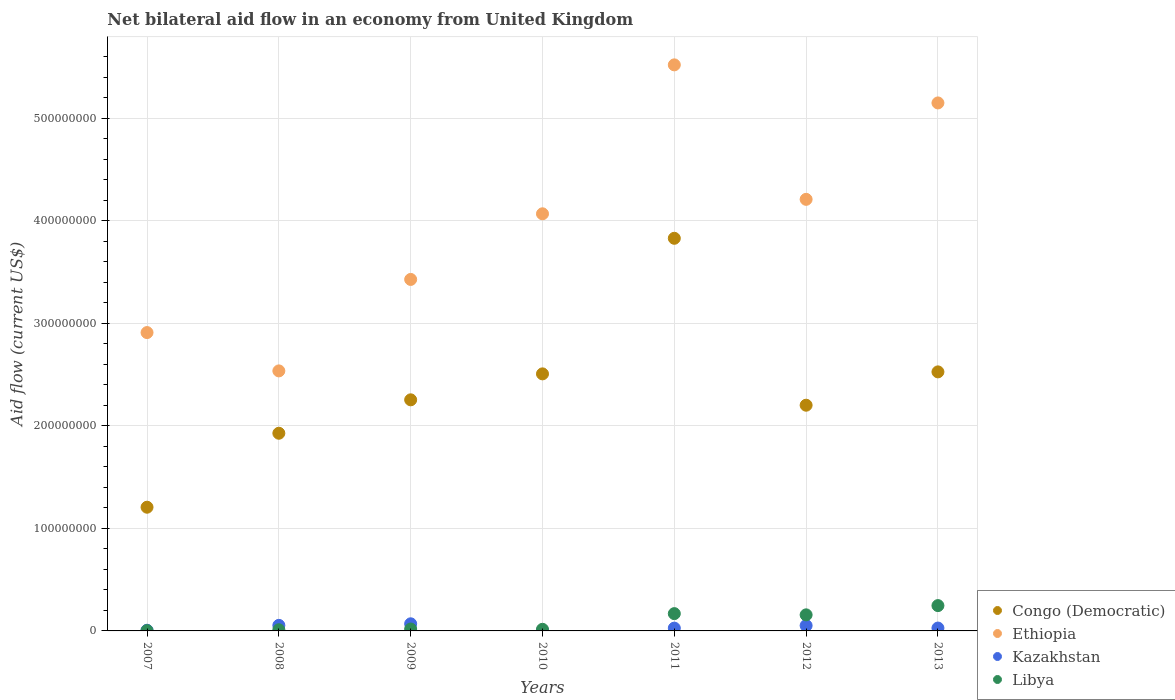How many different coloured dotlines are there?
Your response must be concise. 4. Is the number of dotlines equal to the number of legend labels?
Offer a very short reply. Yes. What is the net bilateral aid flow in Kazakhstan in 2012?
Provide a short and direct response. 5.22e+06. Across all years, what is the maximum net bilateral aid flow in Kazakhstan?
Your answer should be very brief. 6.95e+06. Across all years, what is the minimum net bilateral aid flow in Libya?
Keep it short and to the point. 2.90e+05. What is the total net bilateral aid flow in Ethiopia in the graph?
Make the answer very short. 2.78e+09. What is the difference between the net bilateral aid flow in Ethiopia in 2007 and that in 2010?
Your response must be concise. -1.16e+08. What is the difference between the net bilateral aid flow in Libya in 2013 and the net bilateral aid flow in Ethiopia in 2009?
Give a very brief answer. -3.18e+08. What is the average net bilateral aid flow in Ethiopia per year?
Give a very brief answer. 3.98e+08. In the year 2007, what is the difference between the net bilateral aid flow in Congo (Democratic) and net bilateral aid flow in Kazakhstan?
Offer a terse response. 1.20e+08. In how many years, is the net bilateral aid flow in Congo (Democratic) greater than 380000000 US$?
Offer a very short reply. 1. What is the ratio of the net bilateral aid flow in Kazakhstan in 2007 to that in 2011?
Provide a short and direct response. 0.24. Is the difference between the net bilateral aid flow in Congo (Democratic) in 2011 and 2013 greater than the difference between the net bilateral aid flow in Kazakhstan in 2011 and 2013?
Provide a succinct answer. Yes. What is the difference between the highest and the second highest net bilateral aid flow in Ethiopia?
Provide a short and direct response. 3.71e+07. What is the difference between the highest and the lowest net bilateral aid flow in Congo (Democratic)?
Your answer should be very brief. 2.62e+08. Is the sum of the net bilateral aid flow in Libya in 2008 and 2010 greater than the maximum net bilateral aid flow in Ethiopia across all years?
Give a very brief answer. No. Does the net bilateral aid flow in Libya monotonically increase over the years?
Provide a succinct answer. No. How many dotlines are there?
Offer a very short reply. 4. How many years are there in the graph?
Offer a very short reply. 7. Are the values on the major ticks of Y-axis written in scientific E-notation?
Make the answer very short. No. Does the graph contain any zero values?
Give a very brief answer. No. Does the graph contain grids?
Make the answer very short. Yes. Where does the legend appear in the graph?
Ensure brevity in your answer.  Bottom right. How are the legend labels stacked?
Offer a terse response. Vertical. What is the title of the graph?
Your answer should be compact. Net bilateral aid flow in an economy from United Kingdom. What is the Aid flow (current US$) in Congo (Democratic) in 2007?
Offer a very short reply. 1.21e+08. What is the Aid flow (current US$) of Ethiopia in 2007?
Your response must be concise. 2.91e+08. What is the Aid flow (current US$) of Congo (Democratic) in 2008?
Make the answer very short. 1.93e+08. What is the Aid flow (current US$) in Ethiopia in 2008?
Your answer should be very brief. 2.54e+08. What is the Aid flow (current US$) of Kazakhstan in 2008?
Your answer should be very brief. 5.42e+06. What is the Aid flow (current US$) of Libya in 2008?
Your answer should be compact. 1.14e+06. What is the Aid flow (current US$) in Congo (Democratic) in 2009?
Make the answer very short. 2.25e+08. What is the Aid flow (current US$) of Ethiopia in 2009?
Your answer should be compact. 3.43e+08. What is the Aid flow (current US$) in Kazakhstan in 2009?
Provide a short and direct response. 6.95e+06. What is the Aid flow (current US$) in Libya in 2009?
Ensure brevity in your answer.  1.86e+06. What is the Aid flow (current US$) in Congo (Democratic) in 2010?
Give a very brief answer. 2.51e+08. What is the Aid flow (current US$) in Ethiopia in 2010?
Offer a very short reply. 4.07e+08. What is the Aid flow (current US$) in Libya in 2010?
Offer a very short reply. 1.58e+06. What is the Aid flow (current US$) in Congo (Democratic) in 2011?
Keep it short and to the point. 3.83e+08. What is the Aid flow (current US$) in Ethiopia in 2011?
Your answer should be compact. 5.52e+08. What is the Aid flow (current US$) of Kazakhstan in 2011?
Your answer should be compact. 2.73e+06. What is the Aid flow (current US$) in Libya in 2011?
Make the answer very short. 1.69e+07. What is the Aid flow (current US$) in Congo (Democratic) in 2012?
Your response must be concise. 2.20e+08. What is the Aid flow (current US$) in Ethiopia in 2012?
Keep it short and to the point. 4.21e+08. What is the Aid flow (current US$) of Kazakhstan in 2012?
Offer a terse response. 5.22e+06. What is the Aid flow (current US$) in Libya in 2012?
Your response must be concise. 1.57e+07. What is the Aid flow (current US$) in Congo (Democratic) in 2013?
Your answer should be compact. 2.53e+08. What is the Aid flow (current US$) in Ethiopia in 2013?
Your response must be concise. 5.15e+08. What is the Aid flow (current US$) of Kazakhstan in 2013?
Keep it short and to the point. 2.80e+06. What is the Aid flow (current US$) in Libya in 2013?
Ensure brevity in your answer.  2.47e+07. Across all years, what is the maximum Aid flow (current US$) in Congo (Democratic)?
Your answer should be very brief. 3.83e+08. Across all years, what is the maximum Aid flow (current US$) in Ethiopia?
Your response must be concise. 5.52e+08. Across all years, what is the maximum Aid flow (current US$) in Kazakhstan?
Offer a very short reply. 6.95e+06. Across all years, what is the maximum Aid flow (current US$) of Libya?
Keep it short and to the point. 2.47e+07. Across all years, what is the minimum Aid flow (current US$) of Congo (Democratic)?
Give a very brief answer. 1.21e+08. Across all years, what is the minimum Aid flow (current US$) in Ethiopia?
Ensure brevity in your answer.  2.54e+08. Across all years, what is the minimum Aid flow (current US$) in Kazakhstan?
Keep it short and to the point. 3.40e+05. What is the total Aid flow (current US$) in Congo (Democratic) in the graph?
Offer a terse response. 1.65e+09. What is the total Aid flow (current US$) of Ethiopia in the graph?
Ensure brevity in your answer.  2.78e+09. What is the total Aid flow (current US$) of Kazakhstan in the graph?
Provide a short and direct response. 2.41e+07. What is the total Aid flow (current US$) in Libya in the graph?
Your answer should be compact. 6.21e+07. What is the difference between the Aid flow (current US$) of Congo (Democratic) in 2007 and that in 2008?
Your answer should be compact. -7.22e+07. What is the difference between the Aid flow (current US$) of Ethiopia in 2007 and that in 2008?
Offer a terse response. 3.74e+07. What is the difference between the Aid flow (current US$) in Kazakhstan in 2007 and that in 2008?
Provide a succinct answer. -4.76e+06. What is the difference between the Aid flow (current US$) in Libya in 2007 and that in 2008?
Your answer should be very brief. -8.50e+05. What is the difference between the Aid flow (current US$) in Congo (Democratic) in 2007 and that in 2009?
Offer a terse response. -1.05e+08. What is the difference between the Aid flow (current US$) of Ethiopia in 2007 and that in 2009?
Your answer should be compact. -5.18e+07. What is the difference between the Aid flow (current US$) of Kazakhstan in 2007 and that in 2009?
Ensure brevity in your answer.  -6.29e+06. What is the difference between the Aid flow (current US$) of Libya in 2007 and that in 2009?
Your answer should be compact. -1.57e+06. What is the difference between the Aid flow (current US$) of Congo (Democratic) in 2007 and that in 2010?
Keep it short and to the point. -1.30e+08. What is the difference between the Aid flow (current US$) in Ethiopia in 2007 and that in 2010?
Your response must be concise. -1.16e+08. What is the difference between the Aid flow (current US$) of Kazakhstan in 2007 and that in 2010?
Offer a terse response. 3.20e+05. What is the difference between the Aid flow (current US$) in Libya in 2007 and that in 2010?
Your answer should be compact. -1.29e+06. What is the difference between the Aid flow (current US$) in Congo (Democratic) in 2007 and that in 2011?
Make the answer very short. -2.62e+08. What is the difference between the Aid flow (current US$) of Ethiopia in 2007 and that in 2011?
Give a very brief answer. -2.61e+08. What is the difference between the Aid flow (current US$) in Kazakhstan in 2007 and that in 2011?
Your response must be concise. -2.07e+06. What is the difference between the Aid flow (current US$) of Libya in 2007 and that in 2011?
Make the answer very short. -1.66e+07. What is the difference between the Aid flow (current US$) in Congo (Democratic) in 2007 and that in 2012?
Provide a succinct answer. -9.95e+07. What is the difference between the Aid flow (current US$) in Ethiopia in 2007 and that in 2012?
Your answer should be compact. -1.30e+08. What is the difference between the Aid flow (current US$) in Kazakhstan in 2007 and that in 2012?
Your answer should be very brief. -4.56e+06. What is the difference between the Aid flow (current US$) of Libya in 2007 and that in 2012?
Provide a short and direct response. -1.54e+07. What is the difference between the Aid flow (current US$) of Congo (Democratic) in 2007 and that in 2013?
Make the answer very short. -1.32e+08. What is the difference between the Aid flow (current US$) of Ethiopia in 2007 and that in 2013?
Provide a short and direct response. -2.24e+08. What is the difference between the Aid flow (current US$) of Kazakhstan in 2007 and that in 2013?
Make the answer very short. -2.14e+06. What is the difference between the Aid flow (current US$) of Libya in 2007 and that in 2013?
Offer a terse response. -2.44e+07. What is the difference between the Aid flow (current US$) of Congo (Democratic) in 2008 and that in 2009?
Offer a very short reply. -3.26e+07. What is the difference between the Aid flow (current US$) of Ethiopia in 2008 and that in 2009?
Your answer should be compact. -8.92e+07. What is the difference between the Aid flow (current US$) in Kazakhstan in 2008 and that in 2009?
Your response must be concise. -1.53e+06. What is the difference between the Aid flow (current US$) of Libya in 2008 and that in 2009?
Keep it short and to the point. -7.20e+05. What is the difference between the Aid flow (current US$) of Congo (Democratic) in 2008 and that in 2010?
Keep it short and to the point. -5.79e+07. What is the difference between the Aid flow (current US$) in Ethiopia in 2008 and that in 2010?
Provide a short and direct response. -1.53e+08. What is the difference between the Aid flow (current US$) in Kazakhstan in 2008 and that in 2010?
Offer a terse response. 5.08e+06. What is the difference between the Aid flow (current US$) in Libya in 2008 and that in 2010?
Your answer should be very brief. -4.40e+05. What is the difference between the Aid flow (current US$) of Congo (Democratic) in 2008 and that in 2011?
Provide a succinct answer. -1.90e+08. What is the difference between the Aid flow (current US$) in Ethiopia in 2008 and that in 2011?
Keep it short and to the point. -2.99e+08. What is the difference between the Aid flow (current US$) of Kazakhstan in 2008 and that in 2011?
Offer a terse response. 2.69e+06. What is the difference between the Aid flow (current US$) in Libya in 2008 and that in 2011?
Provide a short and direct response. -1.57e+07. What is the difference between the Aid flow (current US$) of Congo (Democratic) in 2008 and that in 2012?
Your answer should be very brief. -2.74e+07. What is the difference between the Aid flow (current US$) of Ethiopia in 2008 and that in 2012?
Your response must be concise. -1.67e+08. What is the difference between the Aid flow (current US$) in Kazakhstan in 2008 and that in 2012?
Your response must be concise. 2.00e+05. What is the difference between the Aid flow (current US$) of Libya in 2008 and that in 2012?
Provide a short and direct response. -1.45e+07. What is the difference between the Aid flow (current US$) of Congo (Democratic) in 2008 and that in 2013?
Make the answer very short. -5.99e+07. What is the difference between the Aid flow (current US$) of Ethiopia in 2008 and that in 2013?
Provide a short and direct response. -2.61e+08. What is the difference between the Aid flow (current US$) in Kazakhstan in 2008 and that in 2013?
Your answer should be compact. 2.62e+06. What is the difference between the Aid flow (current US$) in Libya in 2008 and that in 2013?
Provide a succinct answer. -2.36e+07. What is the difference between the Aid flow (current US$) of Congo (Democratic) in 2009 and that in 2010?
Your answer should be very brief. -2.53e+07. What is the difference between the Aid flow (current US$) of Ethiopia in 2009 and that in 2010?
Offer a terse response. -6.40e+07. What is the difference between the Aid flow (current US$) of Kazakhstan in 2009 and that in 2010?
Your response must be concise. 6.61e+06. What is the difference between the Aid flow (current US$) of Congo (Democratic) in 2009 and that in 2011?
Ensure brevity in your answer.  -1.58e+08. What is the difference between the Aid flow (current US$) of Ethiopia in 2009 and that in 2011?
Offer a terse response. -2.09e+08. What is the difference between the Aid flow (current US$) of Kazakhstan in 2009 and that in 2011?
Your response must be concise. 4.22e+06. What is the difference between the Aid flow (current US$) in Libya in 2009 and that in 2011?
Ensure brevity in your answer.  -1.50e+07. What is the difference between the Aid flow (current US$) of Congo (Democratic) in 2009 and that in 2012?
Offer a terse response. 5.26e+06. What is the difference between the Aid flow (current US$) of Ethiopia in 2009 and that in 2012?
Provide a short and direct response. -7.81e+07. What is the difference between the Aid flow (current US$) of Kazakhstan in 2009 and that in 2012?
Your answer should be compact. 1.73e+06. What is the difference between the Aid flow (current US$) of Libya in 2009 and that in 2012?
Your answer should be compact. -1.38e+07. What is the difference between the Aid flow (current US$) in Congo (Democratic) in 2009 and that in 2013?
Keep it short and to the point. -2.73e+07. What is the difference between the Aid flow (current US$) of Ethiopia in 2009 and that in 2013?
Provide a succinct answer. -1.72e+08. What is the difference between the Aid flow (current US$) of Kazakhstan in 2009 and that in 2013?
Provide a short and direct response. 4.15e+06. What is the difference between the Aid flow (current US$) of Libya in 2009 and that in 2013?
Keep it short and to the point. -2.28e+07. What is the difference between the Aid flow (current US$) of Congo (Democratic) in 2010 and that in 2011?
Offer a very short reply. -1.32e+08. What is the difference between the Aid flow (current US$) in Ethiopia in 2010 and that in 2011?
Offer a terse response. -1.45e+08. What is the difference between the Aid flow (current US$) of Kazakhstan in 2010 and that in 2011?
Your response must be concise. -2.39e+06. What is the difference between the Aid flow (current US$) in Libya in 2010 and that in 2011?
Provide a succinct answer. -1.53e+07. What is the difference between the Aid flow (current US$) in Congo (Democratic) in 2010 and that in 2012?
Offer a terse response. 3.06e+07. What is the difference between the Aid flow (current US$) of Ethiopia in 2010 and that in 2012?
Ensure brevity in your answer.  -1.41e+07. What is the difference between the Aid flow (current US$) in Kazakhstan in 2010 and that in 2012?
Provide a short and direct response. -4.88e+06. What is the difference between the Aid flow (current US$) of Libya in 2010 and that in 2012?
Provide a succinct answer. -1.41e+07. What is the difference between the Aid flow (current US$) in Congo (Democratic) in 2010 and that in 2013?
Ensure brevity in your answer.  -1.94e+06. What is the difference between the Aid flow (current US$) of Ethiopia in 2010 and that in 2013?
Provide a succinct answer. -1.08e+08. What is the difference between the Aid flow (current US$) in Kazakhstan in 2010 and that in 2013?
Offer a very short reply. -2.46e+06. What is the difference between the Aid flow (current US$) in Libya in 2010 and that in 2013?
Offer a very short reply. -2.31e+07. What is the difference between the Aid flow (current US$) of Congo (Democratic) in 2011 and that in 2012?
Provide a short and direct response. 1.63e+08. What is the difference between the Aid flow (current US$) of Ethiopia in 2011 and that in 2012?
Provide a short and direct response. 1.31e+08. What is the difference between the Aid flow (current US$) in Kazakhstan in 2011 and that in 2012?
Make the answer very short. -2.49e+06. What is the difference between the Aid flow (current US$) of Libya in 2011 and that in 2012?
Your answer should be compact. 1.19e+06. What is the difference between the Aid flow (current US$) of Congo (Democratic) in 2011 and that in 2013?
Make the answer very short. 1.30e+08. What is the difference between the Aid flow (current US$) of Ethiopia in 2011 and that in 2013?
Your answer should be compact. 3.71e+07. What is the difference between the Aid flow (current US$) of Libya in 2011 and that in 2013?
Provide a succinct answer. -7.83e+06. What is the difference between the Aid flow (current US$) of Congo (Democratic) in 2012 and that in 2013?
Provide a short and direct response. -3.25e+07. What is the difference between the Aid flow (current US$) in Ethiopia in 2012 and that in 2013?
Provide a short and direct response. -9.41e+07. What is the difference between the Aid flow (current US$) in Kazakhstan in 2012 and that in 2013?
Make the answer very short. 2.42e+06. What is the difference between the Aid flow (current US$) in Libya in 2012 and that in 2013?
Give a very brief answer. -9.02e+06. What is the difference between the Aid flow (current US$) of Congo (Democratic) in 2007 and the Aid flow (current US$) of Ethiopia in 2008?
Your answer should be compact. -1.33e+08. What is the difference between the Aid flow (current US$) in Congo (Democratic) in 2007 and the Aid flow (current US$) in Kazakhstan in 2008?
Keep it short and to the point. 1.15e+08. What is the difference between the Aid flow (current US$) of Congo (Democratic) in 2007 and the Aid flow (current US$) of Libya in 2008?
Your answer should be compact. 1.20e+08. What is the difference between the Aid flow (current US$) of Ethiopia in 2007 and the Aid flow (current US$) of Kazakhstan in 2008?
Offer a terse response. 2.86e+08. What is the difference between the Aid flow (current US$) in Ethiopia in 2007 and the Aid flow (current US$) in Libya in 2008?
Make the answer very short. 2.90e+08. What is the difference between the Aid flow (current US$) in Kazakhstan in 2007 and the Aid flow (current US$) in Libya in 2008?
Your response must be concise. -4.80e+05. What is the difference between the Aid flow (current US$) of Congo (Democratic) in 2007 and the Aid flow (current US$) of Ethiopia in 2009?
Make the answer very short. -2.22e+08. What is the difference between the Aid flow (current US$) in Congo (Democratic) in 2007 and the Aid flow (current US$) in Kazakhstan in 2009?
Give a very brief answer. 1.14e+08. What is the difference between the Aid flow (current US$) of Congo (Democratic) in 2007 and the Aid flow (current US$) of Libya in 2009?
Offer a terse response. 1.19e+08. What is the difference between the Aid flow (current US$) of Ethiopia in 2007 and the Aid flow (current US$) of Kazakhstan in 2009?
Your answer should be compact. 2.84e+08. What is the difference between the Aid flow (current US$) of Ethiopia in 2007 and the Aid flow (current US$) of Libya in 2009?
Provide a short and direct response. 2.89e+08. What is the difference between the Aid flow (current US$) of Kazakhstan in 2007 and the Aid flow (current US$) of Libya in 2009?
Keep it short and to the point. -1.20e+06. What is the difference between the Aid flow (current US$) in Congo (Democratic) in 2007 and the Aid flow (current US$) in Ethiopia in 2010?
Your response must be concise. -2.86e+08. What is the difference between the Aid flow (current US$) in Congo (Democratic) in 2007 and the Aid flow (current US$) in Kazakhstan in 2010?
Offer a terse response. 1.20e+08. What is the difference between the Aid flow (current US$) in Congo (Democratic) in 2007 and the Aid flow (current US$) in Libya in 2010?
Your answer should be very brief. 1.19e+08. What is the difference between the Aid flow (current US$) of Ethiopia in 2007 and the Aid flow (current US$) of Kazakhstan in 2010?
Offer a very short reply. 2.91e+08. What is the difference between the Aid flow (current US$) in Ethiopia in 2007 and the Aid flow (current US$) in Libya in 2010?
Give a very brief answer. 2.89e+08. What is the difference between the Aid flow (current US$) in Kazakhstan in 2007 and the Aid flow (current US$) in Libya in 2010?
Your answer should be very brief. -9.20e+05. What is the difference between the Aid flow (current US$) of Congo (Democratic) in 2007 and the Aid flow (current US$) of Ethiopia in 2011?
Provide a succinct answer. -4.32e+08. What is the difference between the Aid flow (current US$) in Congo (Democratic) in 2007 and the Aid flow (current US$) in Kazakhstan in 2011?
Provide a succinct answer. 1.18e+08. What is the difference between the Aid flow (current US$) in Congo (Democratic) in 2007 and the Aid flow (current US$) in Libya in 2011?
Your answer should be very brief. 1.04e+08. What is the difference between the Aid flow (current US$) in Ethiopia in 2007 and the Aid flow (current US$) in Kazakhstan in 2011?
Your answer should be very brief. 2.88e+08. What is the difference between the Aid flow (current US$) of Ethiopia in 2007 and the Aid flow (current US$) of Libya in 2011?
Offer a very short reply. 2.74e+08. What is the difference between the Aid flow (current US$) of Kazakhstan in 2007 and the Aid flow (current US$) of Libya in 2011?
Give a very brief answer. -1.62e+07. What is the difference between the Aid flow (current US$) in Congo (Democratic) in 2007 and the Aid flow (current US$) in Ethiopia in 2012?
Provide a succinct answer. -3.00e+08. What is the difference between the Aid flow (current US$) of Congo (Democratic) in 2007 and the Aid flow (current US$) of Kazakhstan in 2012?
Give a very brief answer. 1.15e+08. What is the difference between the Aid flow (current US$) in Congo (Democratic) in 2007 and the Aid flow (current US$) in Libya in 2012?
Ensure brevity in your answer.  1.05e+08. What is the difference between the Aid flow (current US$) in Ethiopia in 2007 and the Aid flow (current US$) in Kazakhstan in 2012?
Ensure brevity in your answer.  2.86e+08. What is the difference between the Aid flow (current US$) in Ethiopia in 2007 and the Aid flow (current US$) in Libya in 2012?
Ensure brevity in your answer.  2.75e+08. What is the difference between the Aid flow (current US$) in Kazakhstan in 2007 and the Aid flow (current US$) in Libya in 2012?
Make the answer very short. -1.50e+07. What is the difference between the Aid flow (current US$) in Congo (Democratic) in 2007 and the Aid flow (current US$) in Ethiopia in 2013?
Your answer should be compact. -3.94e+08. What is the difference between the Aid flow (current US$) in Congo (Democratic) in 2007 and the Aid flow (current US$) in Kazakhstan in 2013?
Offer a terse response. 1.18e+08. What is the difference between the Aid flow (current US$) in Congo (Democratic) in 2007 and the Aid flow (current US$) in Libya in 2013?
Keep it short and to the point. 9.60e+07. What is the difference between the Aid flow (current US$) of Ethiopia in 2007 and the Aid flow (current US$) of Kazakhstan in 2013?
Make the answer very short. 2.88e+08. What is the difference between the Aid flow (current US$) in Ethiopia in 2007 and the Aid flow (current US$) in Libya in 2013?
Offer a terse response. 2.66e+08. What is the difference between the Aid flow (current US$) in Kazakhstan in 2007 and the Aid flow (current US$) in Libya in 2013?
Offer a terse response. -2.40e+07. What is the difference between the Aid flow (current US$) of Congo (Democratic) in 2008 and the Aid flow (current US$) of Ethiopia in 2009?
Your response must be concise. -1.50e+08. What is the difference between the Aid flow (current US$) in Congo (Democratic) in 2008 and the Aid flow (current US$) in Kazakhstan in 2009?
Your response must be concise. 1.86e+08. What is the difference between the Aid flow (current US$) in Congo (Democratic) in 2008 and the Aid flow (current US$) in Libya in 2009?
Provide a short and direct response. 1.91e+08. What is the difference between the Aid flow (current US$) of Ethiopia in 2008 and the Aid flow (current US$) of Kazakhstan in 2009?
Your response must be concise. 2.47e+08. What is the difference between the Aid flow (current US$) in Ethiopia in 2008 and the Aid flow (current US$) in Libya in 2009?
Ensure brevity in your answer.  2.52e+08. What is the difference between the Aid flow (current US$) in Kazakhstan in 2008 and the Aid flow (current US$) in Libya in 2009?
Your answer should be compact. 3.56e+06. What is the difference between the Aid flow (current US$) in Congo (Democratic) in 2008 and the Aid flow (current US$) in Ethiopia in 2010?
Keep it short and to the point. -2.14e+08. What is the difference between the Aid flow (current US$) in Congo (Democratic) in 2008 and the Aid flow (current US$) in Kazakhstan in 2010?
Your response must be concise. 1.93e+08. What is the difference between the Aid flow (current US$) of Congo (Democratic) in 2008 and the Aid flow (current US$) of Libya in 2010?
Your response must be concise. 1.91e+08. What is the difference between the Aid flow (current US$) of Ethiopia in 2008 and the Aid flow (current US$) of Kazakhstan in 2010?
Offer a very short reply. 2.53e+08. What is the difference between the Aid flow (current US$) of Ethiopia in 2008 and the Aid flow (current US$) of Libya in 2010?
Your answer should be compact. 2.52e+08. What is the difference between the Aid flow (current US$) of Kazakhstan in 2008 and the Aid flow (current US$) of Libya in 2010?
Keep it short and to the point. 3.84e+06. What is the difference between the Aid flow (current US$) in Congo (Democratic) in 2008 and the Aid flow (current US$) in Ethiopia in 2011?
Your answer should be very brief. -3.59e+08. What is the difference between the Aid flow (current US$) of Congo (Democratic) in 2008 and the Aid flow (current US$) of Kazakhstan in 2011?
Provide a short and direct response. 1.90e+08. What is the difference between the Aid flow (current US$) in Congo (Democratic) in 2008 and the Aid flow (current US$) in Libya in 2011?
Make the answer very short. 1.76e+08. What is the difference between the Aid flow (current US$) of Ethiopia in 2008 and the Aid flow (current US$) of Kazakhstan in 2011?
Offer a very short reply. 2.51e+08. What is the difference between the Aid flow (current US$) in Ethiopia in 2008 and the Aid flow (current US$) in Libya in 2011?
Keep it short and to the point. 2.37e+08. What is the difference between the Aid flow (current US$) in Kazakhstan in 2008 and the Aid flow (current US$) in Libya in 2011?
Offer a very short reply. -1.14e+07. What is the difference between the Aid flow (current US$) in Congo (Democratic) in 2008 and the Aid flow (current US$) in Ethiopia in 2012?
Make the answer very short. -2.28e+08. What is the difference between the Aid flow (current US$) of Congo (Democratic) in 2008 and the Aid flow (current US$) of Kazakhstan in 2012?
Provide a succinct answer. 1.88e+08. What is the difference between the Aid flow (current US$) of Congo (Democratic) in 2008 and the Aid flow (current US$) of Libya in 2012?
Keep it short and to the point. 1.77e+08. What is the difference between the Aid flow (current US$) in Ethiopia in 2008 and the Aid flow (current US$) in Kazakhstan in 2012?
Offer a very short reply. 2.48e+08. What is the difference between the Aid flow (current US$) of Ethiopia in 2008 and the Aid flow (current US$) of Libya in 2012?
Ensure brevity in your answer.  2.38e+08. What is the difference between the Aid flow (current US$) of Kazakhstan in 2008 and the Aid flow (current US$) of Libya in 2012?
Offer a terse response. -1.03e+07. What is the difference between the Aid flow (current US$) in Congo (Democratic) in 2008 and the Aid flow (current US$) in Ethiopia in 2013?
Give a very brief answer. -3.22e+08. What is the difference between the Aid flow (current US$) of Congo (Democratic) in 2008 and the Aid flow (current US$) of Kazakhstan in 2013?
Provide a short and direct response. 1.90e+08. What is the difference between the Aid flow (current US$) of Congo (Democratic) in 2008 and the Aid flow (current US$) of Libya in 2013?
Make the answer very short. 1.68e+08. What is the difference between the Aid flow (current US$) in Ethiopia in 2008 and the Aid flow (current US$) in Kazakhstan in 2013?
Provide a succinct answer. 2.51e+08. What is the difference between the Aid flow (current US$) of Ethiopia in 2008 and the Aid flow (current US$) of Libya in 2013?
Offer a very short reply. 2.29e+08. What is the difference between the Aid flow (current US$) in Kazakhstan in 2008 and the Aid flow (current US$) in Libya in 2013?
Your answer should be very brief. -1.93e+07. What is the difference between the Aid flow (current US$) of Congo (Democratic) in 2009 and the Aid flow (current US$) of Ethiopia in 2010?
Offer a terse response. -1.81e+08. What is the difference between the Aid flow (current US$) of Congo (Democratic) in 2009 and the Aid flow (current US$) of Kazakhstan in 2010?
Provide a short and direct response. 2.25e+08. What is the difference between the Aid flow (current US$) of Congo (Democratic) in 2009 and the Aid flow (current US$) of Libya in 2010?
Provide a short and direct response. 2.24e+08. What is the difference between the Aid flow (current US$) in Ethiopia in 2009 and the Aid flow (current US$) in Kazakhstan in 2010?
Provide a succinct answer. 3.43e+08. What is the difference between the Aid flow (current US$) in Ethiopia in 2009 and the Aid flow (current US$) in Libya in 2010?
Keep it short and to the point. 3.41e+08. What is the difference between the Aid flow (current US$) of Kazakhstan in 2009 and the Aid flow (current US$) of Libya in 2010?
Your answer should be compact. 5.37e+06. What is the difference between the Aid flow (current US$) in Congo (Democratic) in 2009 and the Aid flow (current US$) in Ethiopia in 2011?
Offer a terse response. -3.27e+08. What is the difference between the Aid flow (current US$) of Congo (Democratic) in 2009 and the Aid flow (current US$) of Kazakhstan in 2011?
Your response must be concise. 2.23e+08. What is the difference between the Aid flow (current US$) of Congo (Democratic) in 2009 and the Aid flow (current US$) of Libya in 2011?
Make the answer very short. 2.09e+08. What is the difference between the Aid flow (current US$) in Ethiopia in 2009 and the Aid flow (current US$) in Kazakhstan in 2011?
Your answer should be compact. 3.40e+08. What is the difference between the Aid flow (current US$) in Ethiopia in 2009 and the Aid flow (current US$) in Libya in 2011?
Your response must be concise. 3.26e+08. What is the difference between the Aid flow (current US$) of Kazakhstan in 2009 and the Aid flow (current US$) of Libya in 2011?
Your response must be concise. -9.92e+06. What is the difference between the Aid flow (current US$) in Congo (Democratic) in 2009 and the Aid flow (current US$) in Ethiopia in 2012?
Provide a succinct answer. -1.96e+08. What is the difference between the Aid flow (current US$) of Congo (Democratic) in 2009 and the Aid flow (current US$) of Kazakhstan in 2012?
Offer a terse response. 2.20e+08. What is the difference between the Aid flow (current US$) of Congo (Democratic) in 2009 and the Aid flow (current US$) of Libya in 2012?
Keep it short and to the point. 2.10e+08. What is the difference between the Aid flow (current US$) of Ethiopia in 2009 and the Aid flow (current US$) of Kazakhstan in 2012?
Your answer should be compact. 3.38e+08. What is the difference between the Aid flow (current US$) of Ethiopia in 2009 and the Aid flow (current US$) of Libya in 2012?
Your answer should be compact. 3.27e+08. What is the difference between the Aid flow (current US$) in Kazakhstan in 2009 and the Aid flow (current US$) in Libya in 2012?
Provide a short and direct response. -8.73e+06. What is the difference between the Aid flow (current US$) in Congo (Democratic) in 2009 and the Aid flow (current US$) in Ethiopia in 2013?
Your answer should be very brief. -2.90e+08. What is the difference between the Aid flow (current US$) in Congo (Democratic) in 2009 and the Aid flow (current US$) in Kazakhstan in 2013?
Your answer should be very brief. 2.23e+08. What is the difference between the Aid flow (current US$) in Congo (Democratic) in 2009 and the Aid flow (current US$) in Libya in 2013?
Offer a terse response. 2.01e+08. What is the difference between the Aid flow (current US$) of Ethiopia in 2009 and the Aid flow (current US$) of Kazakhstan in 2013?
Give a very brief answer. 3.40e+08. What is the difference between the Aid flow (current US$) in Ethiopia in 2009 and the Aid flow (current US$) in Libya in 2013?
Your answer should be very brief. 3.18e+08. What is the difference between the Aid flow (current US$) of Kazakhstan in 2009 and the Aid flow (current US$) of Libya in 2013?
Ensure brevity in your answer.  -1.78e+07. What is the difference between the Aid flow (current US$) of Congo (Democratic) in 2010 and the Aid flow (current US$) of Ethiopia in 2011?
Keep it short and to the point. -3.01e+08. What is the difference between the Aid flow (current US$) of Congo (Democratic) in 2010 and the Aid flow (current US$) of Kazakhstan in 2011?
Offer a terse response. 2.48e+08. What is the difference between the Aid flow (current US$) of Congo (Democratic) in 2010 and the Aid flow (current US$) of Libya in 2011?
Provide a short and direct response. 2.34e+08. What is the difference between the Aid flow (current US$) of Ethiopia in 2010 and the Aid flow (current US$) of Kazakhstan in 2011?
Make the answer very short. 4.04e+08. What is the difference between the Aid flow (current US$) in Ethiopia in 2010 and the Aid flow (current US$) in Libya in 2011?
Provide a short and direct response. 3.90e+08. What is the difference between the Aid flow (current US$) in Kazakhstan in 2010 and the Aid flow (current US$) in Libya in 2011?
Offer a terse response. -1.65e+07. What is the difference between the Aid flow (current US$) of Congo (Democratic) in 2010 and the Aid flow (current US$) of Ethiopia in 2012?
Your answer should be very brief. -1.70e+08. What is the difference between the Aid flow (current US$) in Congo (Democratic) in 2010 and the Aid flow (current US$) in Kazakhstan in 2012?
Make the answer very short. 2.46e+08. What is the difference between the Aid flow (current US$) of Congo (Democratic) in 2010 and the Aid flow (current US$) of Libya in 2012?
Provide a succinct answer. 2.35e+08. What is the difference between the Aid flow (current US$) in Ethiopia in 2010 and the Aid flow (current US$) in Kazakhstan in 2012?
Your answer should be compact. 4.02e+08. What is the difference between the Aid flow (current US$) of Ethiopia in 2010 and the Aid flow (current US$) of Libya in 2012?
Your answer should be very brief. 3.91e+08. What is the difference between the Aid flow (current US$) of Kazakhstan in 2010 and the Aid flow (current US$) of Libya in 2012?
Ensure brevity in your answer.  -1.53e+07. What is the difference between the Aid flow (current US$) in Congo (Democratic) in 2010 and the Aid flow (current US$) in Ethiopia in 2013?
Keep it short and to the point. -2.64e+08. What is the difference between the Aid flow (current US$) of Congo (Democratic) in 2010 and the Aid flow (current US$) of Kazakhstan in 2013?
Provide a short and direct response. 2.48e+08. What is the difference between the Aid flow (current US$) in Congo (Democratic) in 2010 and the Aid flow (current US$) in Libya in 2013?
Your answer should be very brief. 2.26e+08. What is the difference between the Aid flow (current US$) of Ethiopia in 2010 and the Aid flow (current US$) of Kazakhstan in 2013?
Offer a very short reply. 4.04e+08. What is the difference between the Aid flow (current US$) in Ethiopia in 2010 and the Aid flow (current US$) in Libya in 2013?
Provide a succinct answer. 3.82e+08. What is the difference between the Aid flow (current US$) in Kazakhstan in 2010 and the Aid flow (current US$) in Libya in 2013?
Your answer should be very brief. -2.44e+07. What is the difference between the Aid flow (current US$) in Congo (Democratic) in 2011 and the Aid flow (current US$) in Ethiopia in 2012?
Your answer should be very brief. -3.80e+07. What is the difference between the Aid flow (current US$) in Congo (Democratic) in 2011 and the Aid flow (current US$) in Kazakhstan in 2012?
Provide a succinct answer. 3.78e+08. What is the difference between the Aid flow (current US$) of Congo (Democratic) in 2011 and the Aid flow (current US$) of Libya in 2012?
Provide a succinct answer. 3.67e+08. What is the difference between the Aid flow (current US$) of Ethiopia in 2011 and the Aid flow (current US$) of Kazakhstan in 2012?
Give a very brief answer. 5.47e+08. What is the difference between the Aid flow (current US$) in Ethiopia in 2011 and the Aid flow (current US$) in Libya in 2012?
Offer a terse response. 5.37e+08. What is the difference between the Aid flow (current US$) in Kazakhstan in 2011 and the Aid flow (current US$) in Libya in 2012?
Your response must be concise. -1.30e+07. What is the difference between the Aid flow (current US$) in Congo (Democratic) in 2011 and the Aid flow (current US$) in Ethiopia in 2013?
Your answer should be very brief. -1.32e+08. What is the difference between the Aid flow (current US$) in Congo (Democratic) in 2011 and the Aid flow (current US$) in Kazakhstan in 2013?
Keep it short and to the point. 3.80e+08. What is the difference between the Aid flow (current US$) in Congo (Democratic) in 2011 and the Aid flow (current US$) in Libya in 2013?
Offer a very short reply. 3.58e+08. What is the difference between the Aid flow (current US$) in Ethiopia in 2011 and the Aid flow (current US$) in Kazakhstan in 2013?
Provide a short and direct response. 5.49e+08. What is the difference between the Aid flow (current US$) of Ethiopia in 2011 and the Aid flow (current US$) of Libya in 2013?
Your answer should be very brief. 5.28e+08. What is the difference between the Aid flow (current US$) of Kazakhstan in 2011 and the Aid flow (current US$) of Libya in 2013?
Provide a short and direct response. -2.20e+07. What is the difference between the Aid flow (current US$) of Congo (Democratic) in 2012 and the Aid flow (current US$) of Ethiopia in 2013?
Ensure brevity in your answer.  -2.95e+08. What is the difference between the Aid flow (current US$) of Congo (Democratic) in 2012 and the Aid flow (current US$) of Kazakhstan in 2013?
Make the answer very short. 2.17e+08. What is the difference between the Aid flow (current US$) in Congo (Democratic) in 2012 and the Aid flow (current US$) in Libya in 2013?
Offer a terse response. 1.96e+08. What is the difference between the Aid flow (current US$) of Ethiopia in 2012 and the Aid flow (current US$) of Kazakhstan in 2013?
Offer a very short reply. 4.18e+08. What is the difference between the Aid flow (current US$) in Ethiopia in 2012 and the Aid flow (current US$) in Libya in 2013?
Keep it short and to the point. 3.96e+08. What is the difference between the Aid flow (current US$) in Kazakhstan in 2012 and the Aid flow (current US$) in Libya in 2013?
Make the answer very short. -1.95e+07. What is the average Aid flow (current US$) of Congo (Democratic) per year?
Your response must be concise. 2.35e+08. What is the average Aid flow (current US$) of Ethiopia per year?
Your answer should be very brief. 3.98e+08. What is the average Aid flow (current US$) of Kazakhstan per year?
Your answer should be very brief. 3.45e+06. What is the average Aid flow (current US$) of Libya per year?
Keep it short and to the point. 8.87e+06. In the year 2007, what is the difference between the Aid flow (current US$) in Congo (Democratic) and Aid flow (current US$) in Ethiopia?
Give a very brief answer. -1.70e+08. In the year 2007, what is the difference between the Aid flow (current US$) of Congo (Democratic) and Aid flow (current US$) of Kazakhstan?
Provide a short and direct response. 1.20e+08. In the year 2007, what is the difference between the Aid flow (current US$) in Congo (Democratic) and Aid flow (current US$) in Libya?
Your answer should be very brief. 1.20e+08. In the year 2007, what is the difference between the Aid flow (current US$) of Ethiopia and Aid flow (current US$) of Kazakhstan?
Make the answer very short. 2.90e+08. In the year 2007, what is the difference between the Aid flow (current US$) in Ethiopia and Aid flow (current US$) in Libya?
Offer a very short reply. 2.91e+08. In the year 2007, what is the difference between the Aid flow (current US$) in Kazakhstan and Aid flow (current US$) in Libya?
Make the answer very short. 3.70e+05. In the year 2008, what is the difference between the Aid flow (current US$) of Congo (Democratic) and Aid flow (current US$) of Ethiopia?
Your answer should be very brief. -6.08e+07. In the year 2008, what is the difference between the Aid flow (current US$) of Congo (Democratic) and Aid flow (current US$) of Kazakhstan?
Provide a short and direct response. 1.87e+08. In the year 2008, what is the difference between the Aid flow (current US$) of Congo (Democratic) and Aid flow (current US$) of Libya?
Provide a short and direct response. 1.92e+08. In the year 2008, what is the difference between the Aid flow (current US$) in Ethiopia and Aid flow (current US$) in Kazakhstan?
Give a very brief answer. 2.48e+08. In the year 2008, what is the difference between the Aid flow (current US$) in Ethiopia and Aid flow (current US$) in Libya?
Make the answer very short. 2.53e+08. In the year 2008, what is the difference between the Aid flow (current US$) in Kazakhstan and Aid flow (current US$) in Libya?
Ensure brevity in your answer.  4.28e+06. In the year 2009, what is the difference between the Aid flow (current US$) in Congo (Democratic) and Aid flow (current US$) in Ethiopia?
Ensure brevity in your answer.  -1.17e+08. In the year 2009, what is the difference between the Aid flow (current US$) in Congo (Democratic) and Aid flow (current US$) in Kazakhstan?
Give a very brief answer. 2.19e+08. In the year 2009, what is the difference between the Aid flow (current US$) of Congo (Democratic) and Aid flow (current US$) of Libya?
Provide a short and direct response. 2.24e+08. In the year 2009, what is the difference between the Aid flow (current US$) of Ethiopia and Aid flow (current US$) of Kazakhstan?
Provide a succinct answer. 3.36e+08. In the year 2009, what is the difference between the Aid flow (current US$) of Ethiopia and Aid flow (current US$) of Libya?
Make the answer very short. 3.41e+08. In the year 2009, what is the difference between the Aid flow (current US$) in Kazakhstan and Aid flow (current US$) in Libya?
Provide a short and direct response. 5.09e+06. In the year 2010, what is the difference between the Aid flow (current US$) of Congo (Democratic) and Aid flow (current US$) of Ethiopia?
Your answer should be very brief. -1.56e+08. In the year 2010, what is the difference between the Aid flow (current US$) in Congo (Democratic) and Aid flow (current US$) in Kazakhstan?
Provide a succinct answer. 2.50e+08. In the year 2010, what is the difference between the Aid flow (current US$) in Congo (Democratic) and Aid flow (current US$) in Libya?
Your response must be concise. 2.49e+08. In the year 2010, what is the difference between the Aid flow (current US$) in Ethiopia and Aid flow (current US$) in Kazakhstan?
Offer a very short reply. 4.07e+08. In the year 2010, what is the difference between the Aid flow (current US$) in Ethiopia and Aid flow (current US$) in Libya?
Make the answer very short. 4.05e+08. In the year 2010, what is the difference between the Aid flow (current US$) of Kazakhstan and Aid flow (current US$) of Libya?
Give a very brief answer. -1.24e+06. In the year 2011, what is the difference between the Aid flow (current US$) of Congo (Democratic) and Aid flow (current US$) of Ethiopia?
Make the answer very short. -1.69e+08. In the year 2011, what is the difference between the Aid flow (current US$) of Congo (Democratic) and Aid flow (current US$) of Kazakhstan?
Give a very brief answer. 3.80e+08. In the year 2011, what is the difference between the Aid flow (current US$) of Congo (Democratic) and Aid flow (current US$) of Libya?
Your answer should be compact. 3.66e+08. In the year 2011, what is the difference between the Aid flow (current US$) in Ethiopia and Aid flow (current US$) in Kazakhstan?
Offer a very short reply. 5.50e+08. In the year 2011, what is the difference between the Aid flow (current US$) of Ethiopia and Aid flow (current US$) of Libya?
Provide a succinct answer. 5.35e+08. In the year 2011, what is the difference between the Aid flow (current US$) in Kazakhstan and Aid flow (current US$) in Libya?
Ensure brevity in your answer.  -1.41e+07. In the year 2012, what is the difference between the Aid flow (current US$) in Congo (Democratic) and Aid flow (current US$) in Ethiopia?
Provide a short and direct response. -2.01e+08. In the year 2012, what is the difference between the Aid flow (current US$) of Congo (Democratic) and Aid flow (current US$) of Kazakhstan?
Provide a succinct answer. 2.15e+08. In the year 2012, what is the difference between the Aid flow (current US$) of Congo (Democratic) and Aid flow (current US$) of Libya?
Your answer should be compact. 2.05e+08. In the year 2012, what is the difference between the Aid flow (current US$) of Ethiopia and Aid flow (current US$) of Kazakhstan?
Your answer should be compact. 4.16e+08. In the year 2012, what is the difference between the Aid flow (current US$) of Ethiopia and Aid flow (current US$) of Libya?
Your answer should be compact. 4.05e+08. In the year 2012, what is the difference between the Aid flow (current US$) of Kazakhstan and Aid flow (current US$) of Libya?
Ensure brevity in your answer.  -1.05e+07. In the year 2013, what is the difference between the Aid flow (current US$) in Congo (Democratic) and Aid flow (current US$) in Ethiopia?
Your response must be concise. -2.62e+08. In the year 2013, what is the difference between the Aid flow (current US$) of Congo (Democratic) and Aid flow (current US$) of Kazakhstan?
Provide a short and direct response. 2.50e+08. In the year 2013, what is the difference between the Aid flow (current US$) in Congo (Democratic) and Aid flow (current US$) in Libya?
Ensure brevity in your answer.  2.28e+08. In the year 2013, what is the difference between the Aid flow (current US$) of Ethiopia and Aid flow (current US$) of Kazakhstan?
Your answer should be compact. 5.12e+08. In the year 2013, what is the difference between the Aid flow (current US$) in Ethiopia and Aid flow (current US$) in Libya?
Offer a terse response. 4.90e+08. In the year 2013, what is the difference between the Aid flow (current US$) in Kazakhstan and Aid flow (current US$) in Libya?
Your answer should be compact. -2.19e+07. What is the ratio of the Aid flow (current US$) of Congo (Democratic) in 2007 to that in 2008?
Your answer should be very brief. 0.63. What is the ratio of the Aid flow (current US$) of Ethiopia in 2007 to that in 2008?
Keep it short and to the point. 1.15. What is the ratio of the Aid flow (current US$) of Kazakhstan in 2007 to that in 2008?
Your answer should be very brief. 0.12. What is the ratio of the Aid flow (current US$) of Libya in 2007 to that in 2008?
Your answer should be compact. 0.25. What is the ratio of the Aid flow (current US$) of Congo (Democratic) in 2007 to that in 2009?
Your answer should be very brief. 0.54. What is the ratio of the Aid flow (current US$) of Ethiopia in 2007 to that in 2009?
Ensure brevity in your answer.  0.85. What is the ratio of the Aid flow (current US$) in Kazakhstan in 2007 to that in 2009?
Provide a short and direct response. 0.1. What is the ratio of the Aid flow (current US$) in Libya in 2007 to that in 2009?
Provide a succinct answer. 0.16. What is the ratio of the Aid flow (current US$) of Congo (Democratic) in 2007 to that in 2010?
Offer a very short reply. 0.48. What is the ratio of the Aid flow (current US$) in Ethiopia in 2007 to that in 2010?
Provide a succinct answer. 0.72. What is the ratio of the Aid flow (current US$) in Kazakhstan in 2007 to that in 2010?
Provide a succinct answer. 1.94. What is the ratio of the Aid flow (current US$) of Libya in 2007 to that in 2010?
Your response must be concise. 0.18. What is the ratio of the Aid flow (current US$) of Congo (Democratic) in 2007 to that in 2011?
Offer a very short reply. 0.32. What is the ratio of the Aid flow (current US$) in Ethiopia in 2007 to that in 2011?
Your answer should be compact. 0.53. What is the ratio of the Aid flow (current US$) of Kazakhstan in 2007 to that in 2011?
Your response must be concise. 0.24. What is the ratio of the Aid flow (current US$) of Libya in 2007 to that in 2011?
Provide a succinct answer. 0.02. What is the ratio of the Aid flow (current US$) of Congo (Democratic) in 2007 to that in 2012?
Your answer should be compact. 0.55. What is the ratio of the Aid flow (current US$) in Ethiopia in 2007 to that in 2012?
Your response must be concise. 0.69. What is the ratio of the Aid flow (current US$) in Kazakhstan in 2007 to that in 2012?
Your answer should be compact. 0.13. What is the ratio of the Aid flow (current US$) of Libya in 2007 to that in 2012?
Provide a succinct answer. 0.02. What is the ratio of the Aid flow (current US$) in Congo (Democratic) in 2007 to that in 2013?
Ensure brevity in your answer.  0.48. What is the ratio of the Aid flow (current US$) of Ethiopia in 2007 to that in 2013?
Offer a very short reply. 0.57. What is the ratio of the Aid flow (current US$) of Kazakhstan in 2007 to that in 2013?
Keep it short and to the point. 0.24. What is the ratio of the Aid flow (current US$) of Libya in 2007 to that in 2013?
Your answer should be compact. 0.01. What is the ratio of the Aid flow (current US$) of Congo (Democratic) in 2008 to that in 2009?
Your answer should be compact. 0.86. What is the ratio of the Aid flow (current US$) of Ethiopia in 2008 to that in 2009?
Make the answer very short. 0.74. What is the ratio of the Aid flow (current US$) of Kazakhstan in 2008 to that in 2009?
Provide a short and direct response. 0.78. What is the ratio of the Aid flow (current US$) in Libya in 2008 to that in 2009?
Provide a succinct answer. 0.61. What is the ratio of the Aid flow (current US$) of Congo (Democratic) in 2008 to that in 2010?
Your answer should be compact. 0.77. What is the ratio of the Aid flow (current US$) of Ethiopia in 2008 to that in 2010?
Provide a short and direct response. 0.62. What is the ratio of the Aid flow (current US$) of Kazakhstan in 2008 to that in 2010?
Your answer should be very brief. 15.94. What is the ratio of the Aid flow (current US$) in Libya in 2008 to that in 2010?
Provide a short and direct response. 0.72. What is the ratio of the Aid flow (current US$) in Congo (Democratic) in 2008 to that in 2011?
Offer a terse response. 0.5. What is the ratio of the Aid flow (current US$) of Ethiopia in 2008 to that in 2011?
Your answer should be compact. 0.46. What is the ratio of the Aid flow (current US$) of Kazakhstan in 2008 to that in 2011?
Make the answer very short. 1.99. What is the ratio of the Aid flow (current US$) of Libya in 2008 to that in 2011?
Keep it short and to the point. 0.07. What is the ratio of the Aid flow (current US$) of Congo (Democratic) in 2008 to that in 2012?
Offer a very short reply. 0.88. What is the ratio of the Aid flow (current US$) of Ethiopia in 2008 to that in 2012?
Offer a terse response. 0.6. What is the ratio of the Aid flow (current US$) in Kazakhstan in 2008 to that in 2012?
Your answer should be compact. 1.04. What is the ratio of the Aid flow (current US$) of Libya in 2008 to that in 2012?
Give a very brief answer. 0.07. What is the ratio of the Aid flow (current US$) of Congo (Democratic) in 2008 to that in 2013?
Provide a succinct answer. 0.76. What is the ratio of the Aid flow (current US$) in Ethiopia in 2008 to that in 2013?
Give a very brief answer. 0.49. What is the ratio of the Aid flow (current US$) of Kazakhstan in 2008 to that in 2013?
Your response must be concise. 1.94. What is the ratio of the Aid flow (current US$) in Libya in 2008 to that in 2013?
Your answer should be very brief. 0.05. What is the ratio of the Aid flow (current US$) of Congo (Democratic) in 2009 to that in 2010?
Your answer should be very brief. 0.9. What is the ratio of the Aid flow (current US$) in Ethiopia in 2009 to that in 2010?
Your answer should be compact. 0.84. What is the ratio of the Aid flow (current US$) of Kazakhstan in 2009 to that in 2010?
Your answer should be very brief. 20.44. What is the ratio of the Aid flow (current US$) in Libya in 2009 to that in 2010?
Keep it short and to the point. 1.18. What is the ratio of the Aid flow (current US$) in Congo (Democratic) in 2009 to that in 2011?
Ensure brevity in your answer.  0.59. What is the ratio of the Aid flow (current US$) in Ethiopia in 2009 to that in 2011?
Offer a terse response. 0.62. What is the ratio of the Aid flow (current US$) in Kazakhstan in 2009 to that in 2011?
Your answer should be very brief. 2.55. What is the ratio of the Aid flow (current US$) in Libya in 2009 to that in 2011?
Provide a short and direct response. 0.11. What is the ratio of the Aid flow (current US$) in Congo (Democratic) in 2009 to that in 2012?
Give a very brief answer. 1.02. What is the ratio of the Aid flow (current US$) of Ethiopia in 2009 to that in 2012?
Your answer should be very brief. 0.81. What is the ratio of the Aid flow (current US$) in Kazakhstan in 2009 to that in 2012?
Offer a terse response. 1.33. What is the ratio of the Aid flow (current US$) of Libya in 2009 to that in 2012?
Provide a succinct answer. 0.12. What is the ratio of the Aid flow (current US$) of Congo (Democratic) in 2009 to that in 2013?
Provide a short and direct response. 0.89. What is the ratio of the Aid flow (current US$) in Ethiopia in 2009 to that in 2013?
Provide a short and direct response. 0.67. What is the ratio of the Aid flow (current US$) in Kazakhstan in 2009 to that in 2013?
Make the answer very short. 2.48. What is the ratio of the Aid flow (current US$) in Libya in 2009 to that in 2013?
Give a very brief answer. 0.08. What is the ratio of the Aid flow (current US$) in Congo (Democratic) in 2010 to that in 2011?
Your answer should be very brief. 0.65. What is the ratio of the Aid flow (current US$) of Ethiopia in 2010 to that in 2011?
Give a very brief answer. 0.74. What is the ratio of the Aid flow (current US$) in Kazakhstan in 2010 to that in 2011?
Make the answer very short. 0.12. What is the ratio of the Aid flow (current US$) in Libya in 2010 to that in 2011?
Offer a very short reply. 0.09. What is the ratio of the Aid flow (current US$) of Congo (Democratic) in 2010 to that in 2012?
Provide a short and direct response. 1.14. What is the ratio of the Aid flow (current US$) in Ethiopia in 2010 to that in 2012?
Your answer should be compact. 0.97. What is the ratio of the Aid flow (current US$) of Kazakhstan in 2010 to that in 2012?
Ensure brevity in your answer.  0.07. What is the ratio of the Aid flow (current US$) in Libya in 2010 to that in 2012?
Provide a short and direct response. 0.1. What is the ratio of the Aid flow (current US$) in Ethiopia in 2010 to that in 2013?
Your answer should be compact. 0.79. What is the ratio of the Aid flow (current US$) of Kazakhstan in 2010 to that in 2013?
Make the answer very short. 0.12. What is the ratio of the Aid flow (current US$) of Libya in 2010 to that in 2013?
Provide a short and direct response. 0.06. What is the ratio of the Aid flow (current US$) in Congo (Democratic) in 2011 to that in 2012?
Ensure brevity in your answer.  1.74. What is the ratio of the Aid flow (current US$) in Ethiopia in 2011 to that in 2012?
Your answer should be very brief. 1.31. What is the ratio of the Aid flow (current US$) of Kazakhstan in 2011 to that in 2012?
Ensure brevity in your answer.  0.52. What is the ratio of the Aid flow (current US$) in Libya in 2011 to that in 2012?
Your response must be concise. 1.08. What is the ratio of the Aid flow (current US$) in Congo (Democratic) in 2011 to that in 2013?
Keep it short and to the point. 1.52. What is the ratio of the Aid flow (current US$) of Ethiopia in 2011 to that in 2013?
Offer a terse response. 1.07. What is the ratio of the Aid flow (current US$) in Kazakhstan in 2011 to that in 2013?
Ensure brevity in your answer.  0.97. What is the ratio of the Aid flow (current US$) in Libya in 2011 to that in 2013?
Provide a short and direct response. 0.68. What is the ratio of the Aid flow (current US$) in Congo (Democratic) in 2012 to that in 2013?
Your response must be concise. 0.87. What is the ratio of the Aid flow (current US$) in Ethiopia in 2012 to that in 2013?
Make the answer very short. 0.82. What is the ratio of the Aid flow (current US$) in Kazakhstan in 2012 to that in 2013?
Your response must be concise. 1.86. What is the ratio of the Aid flow (current US$) in Libya in 2012 to that in 2013?
Ensure brevity in your answer.  0.63. What is the difference between the highest and the second highest Aid flow (current US$) in Congo (Democratic)?
Ensure brevity in your answer.  1.30e+08. What is the difference between the highest and the second highest Aid flow (current US$) of Ethiopia?
Offer a very short reply. 3.71e+07. What is the difference between the highest and the second highest Aid flow (current US$) in Kazakhstan?
Offer a very short reply. 1.53e+06. What is the difference between the highest and the second highest Aid flow (current US$) in Libya?
Offer a terse response. 7.83e+06. What is the difference between the highest and the lowest Aid flow (current US$) in Congo (Democratic)?
Give a very brief answer. 2.62e+08. What is the difference between the highest and the lowest Aid flow (current US$) in Ethiopia?
Your response must be concise. 2.99e+08. What is the difference between the highest and the lowest Aid flow (current US$) in Kazakhstan?
Offer a very short reply. 6.61e+06. What is the difference between the highest and the lowest Aid flow (current US$) of Libya?
Keep it short and to the point. 2.44e+07. 